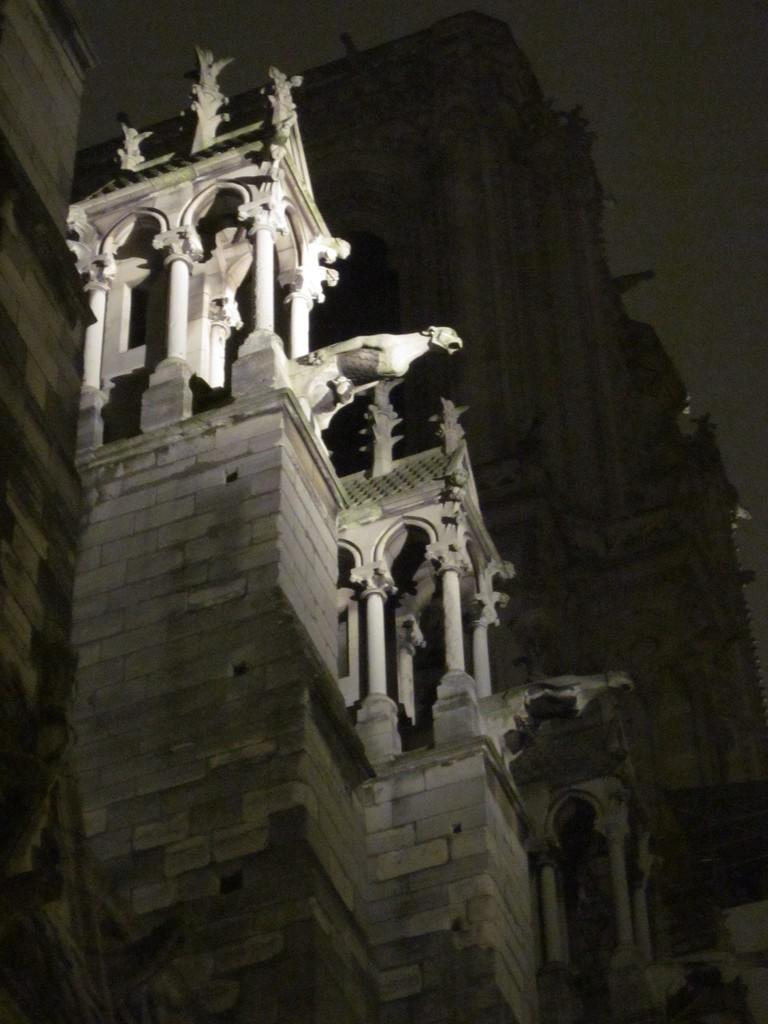What type of structure is visible in the image? There is a building in the image. What architectural features can be seen on the building? There are pillars in the image. Are there any artistic elements present in the image? Yes, there are sculptures in the image. How would you describe the lighting in the image? The background of the image is dark. What type of quiver is being used to hold the dinner in the image? There is no quiver or dinner present in the image; it features a building with pillars and sculptures. 